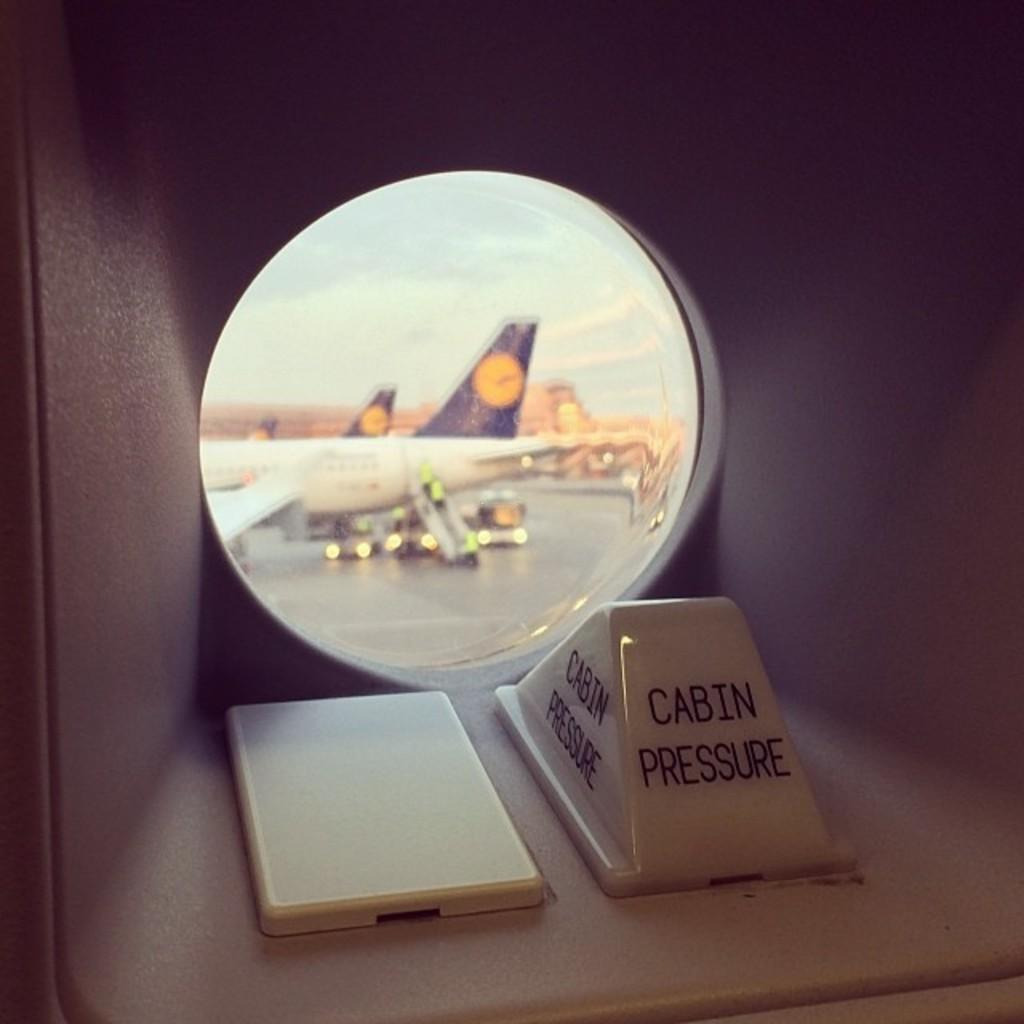What object is present in the image that can reflect images? There is a mirror in the image. What does the mirror reflect in the image? The mirror reflects a white color plane. What type of pet can be seen walking in the image? There is no pet present in the image, and no walking is depicted. 